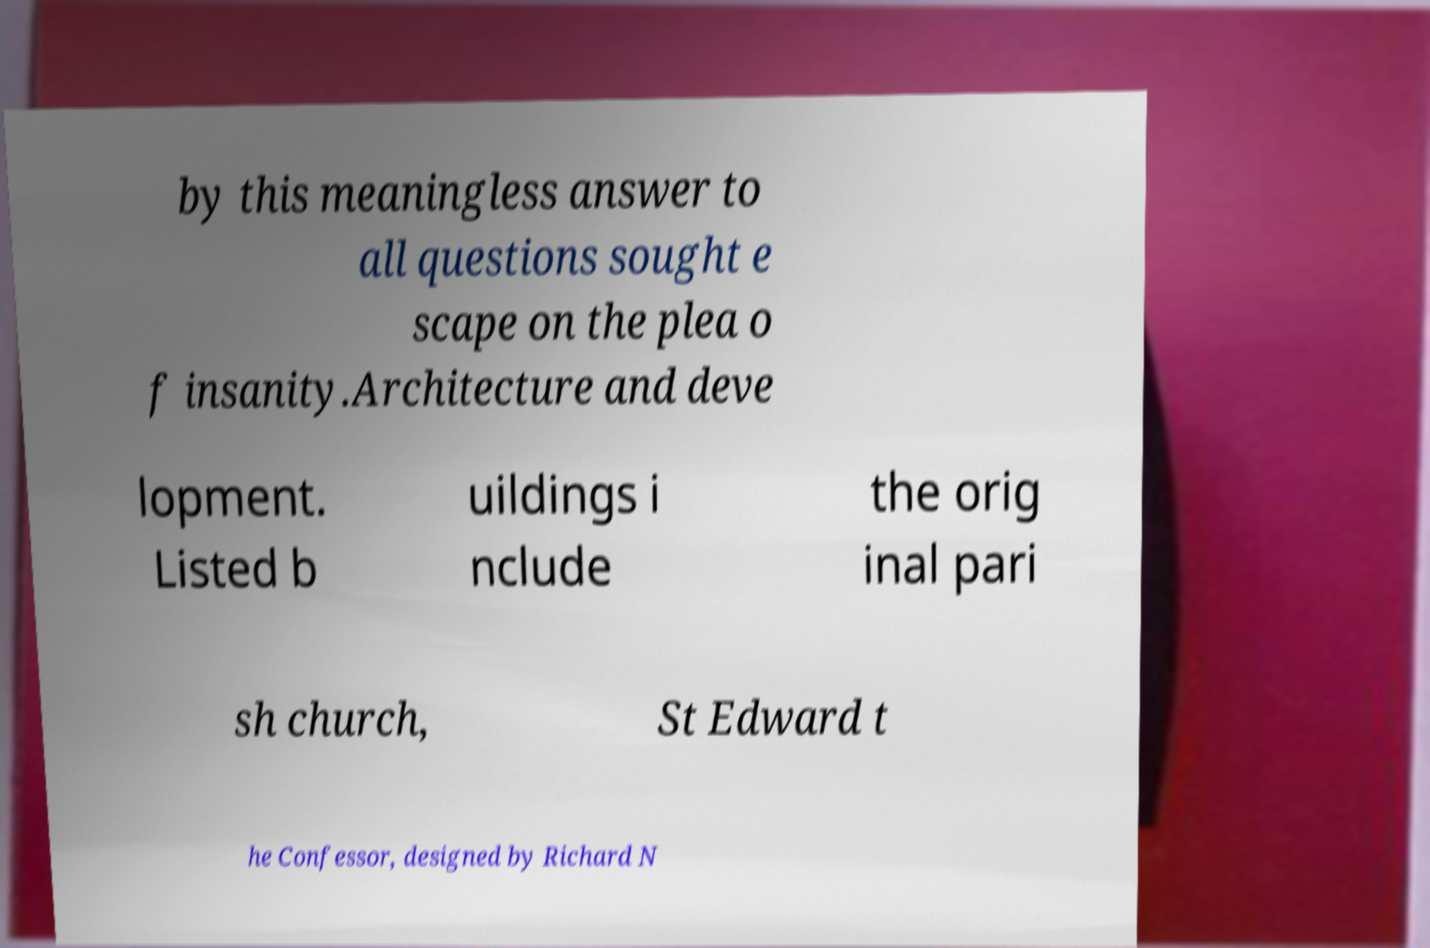Please identify and transcribe the text found in this image. by this meaningless answer to all questions sought e scape on the plea o f insanity.Architecture and deve lopment. Listed b uildings i nclude the orig inal pari sh church, St Edward t he Confessor, designed by Richard N 